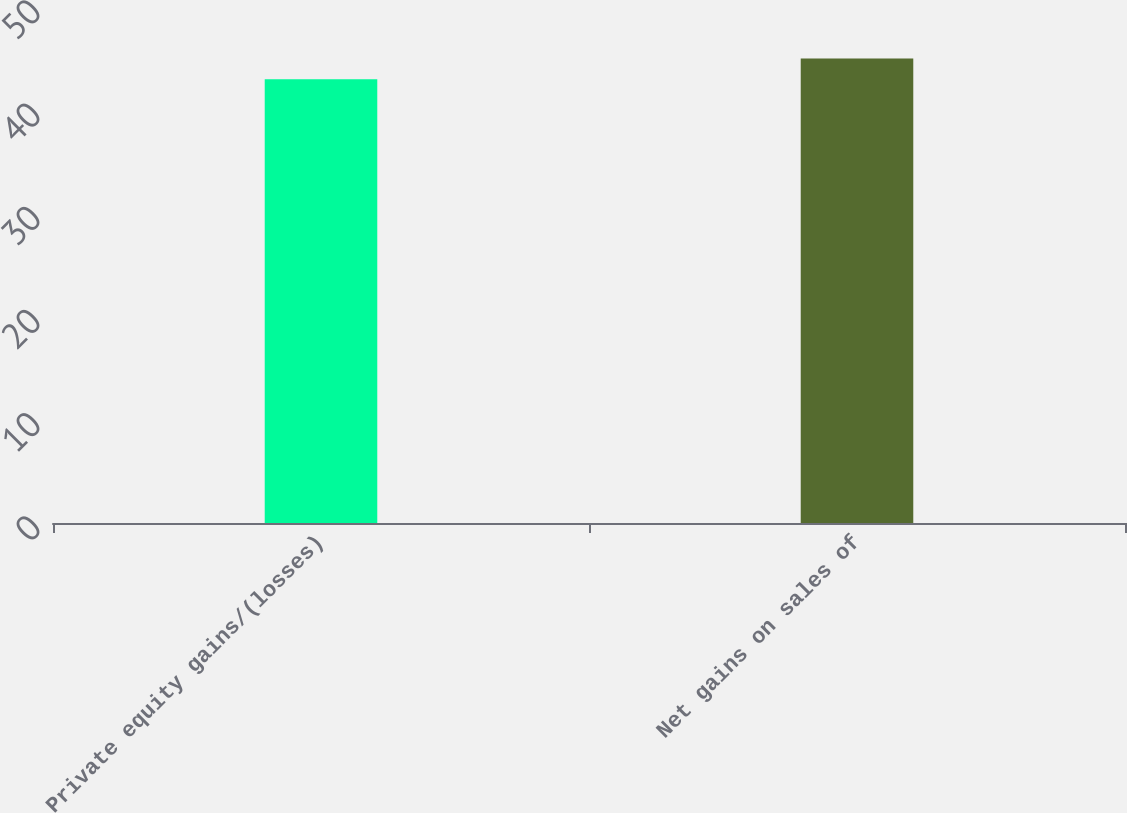<chart> <loc_0><loc_0><loc_500><loc_500><bar_chart><fcel>Private equity gains/(losses)<fcel>Net gains on sales of<nl><fcel>43<fcel>45<nl></chart> 